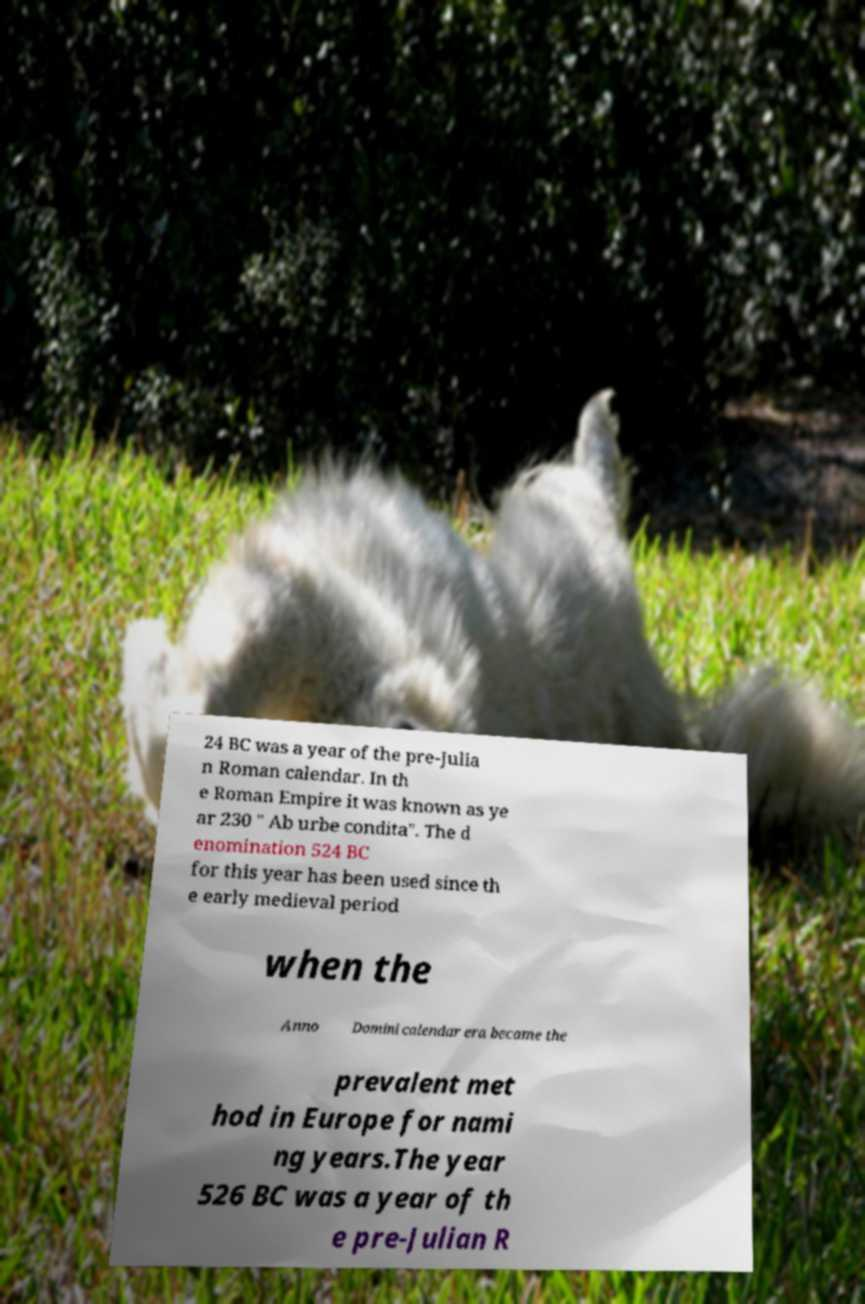Please identify and transcribe the text found in this image. 24 BC was a year of the pre-Julia n Roman calendar. In th e Roman Empire it was known as ye ar 230 " Ab urbe condita". The d enomination 524 BC for this year has been used since th e early medieval period when the Anno Domini calendar era became the prevalent met hod in Europe for nami ng years.The year 526 BC was a year of th e pre-Julian R 